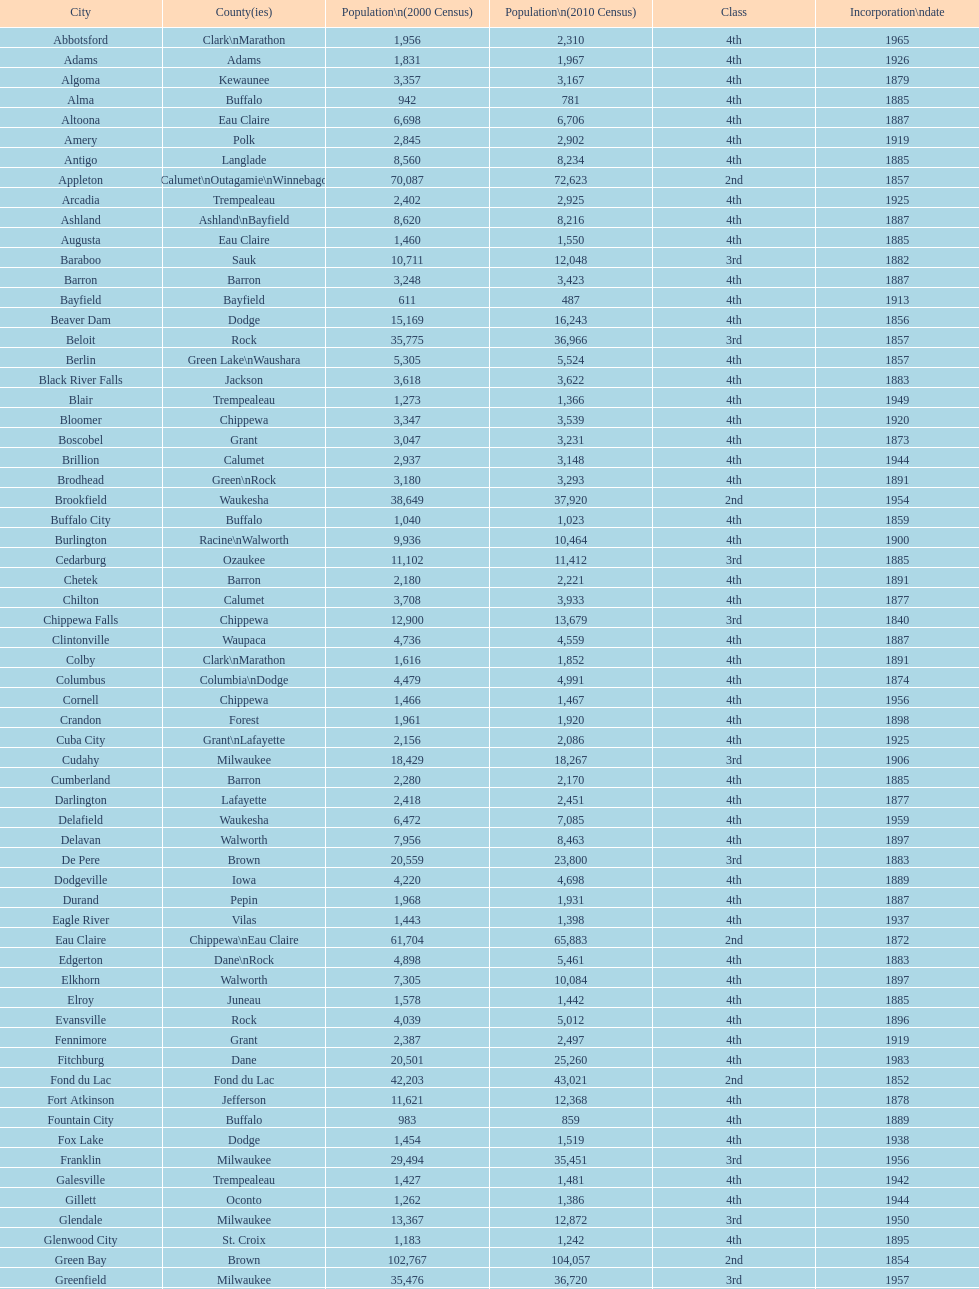Which city holds the title of being the first incorporated city within wisconsin? Chippewa Falls. 